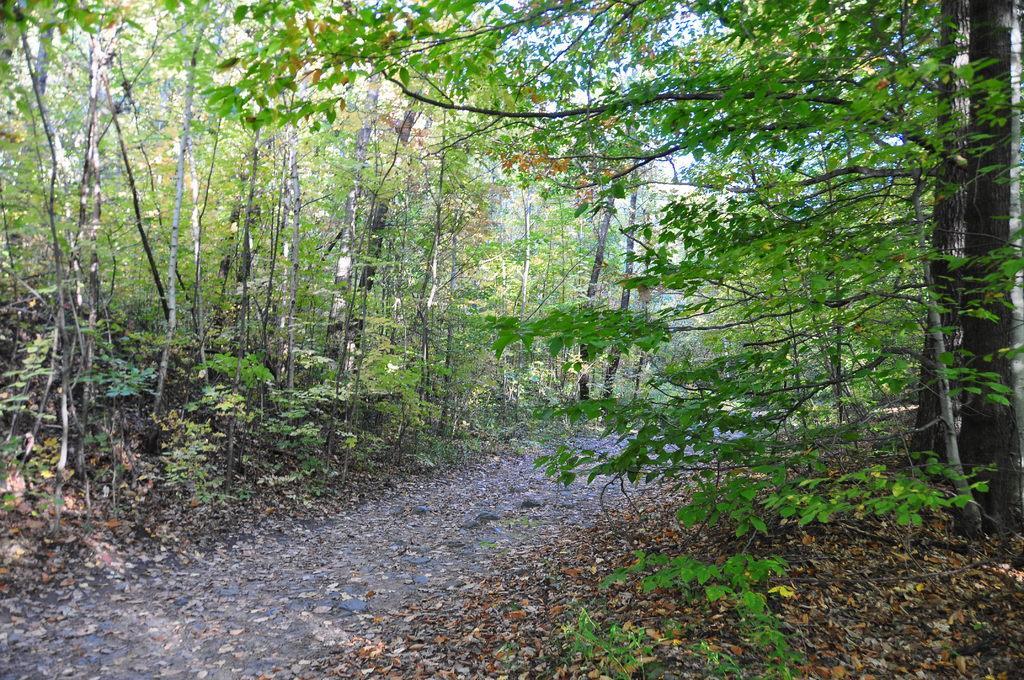How would you summarize this image in a sentence or two? Here we can see a path and there are leaves on the ground. To either side of the path we can see trees. In the background there are clouds in the sky. 